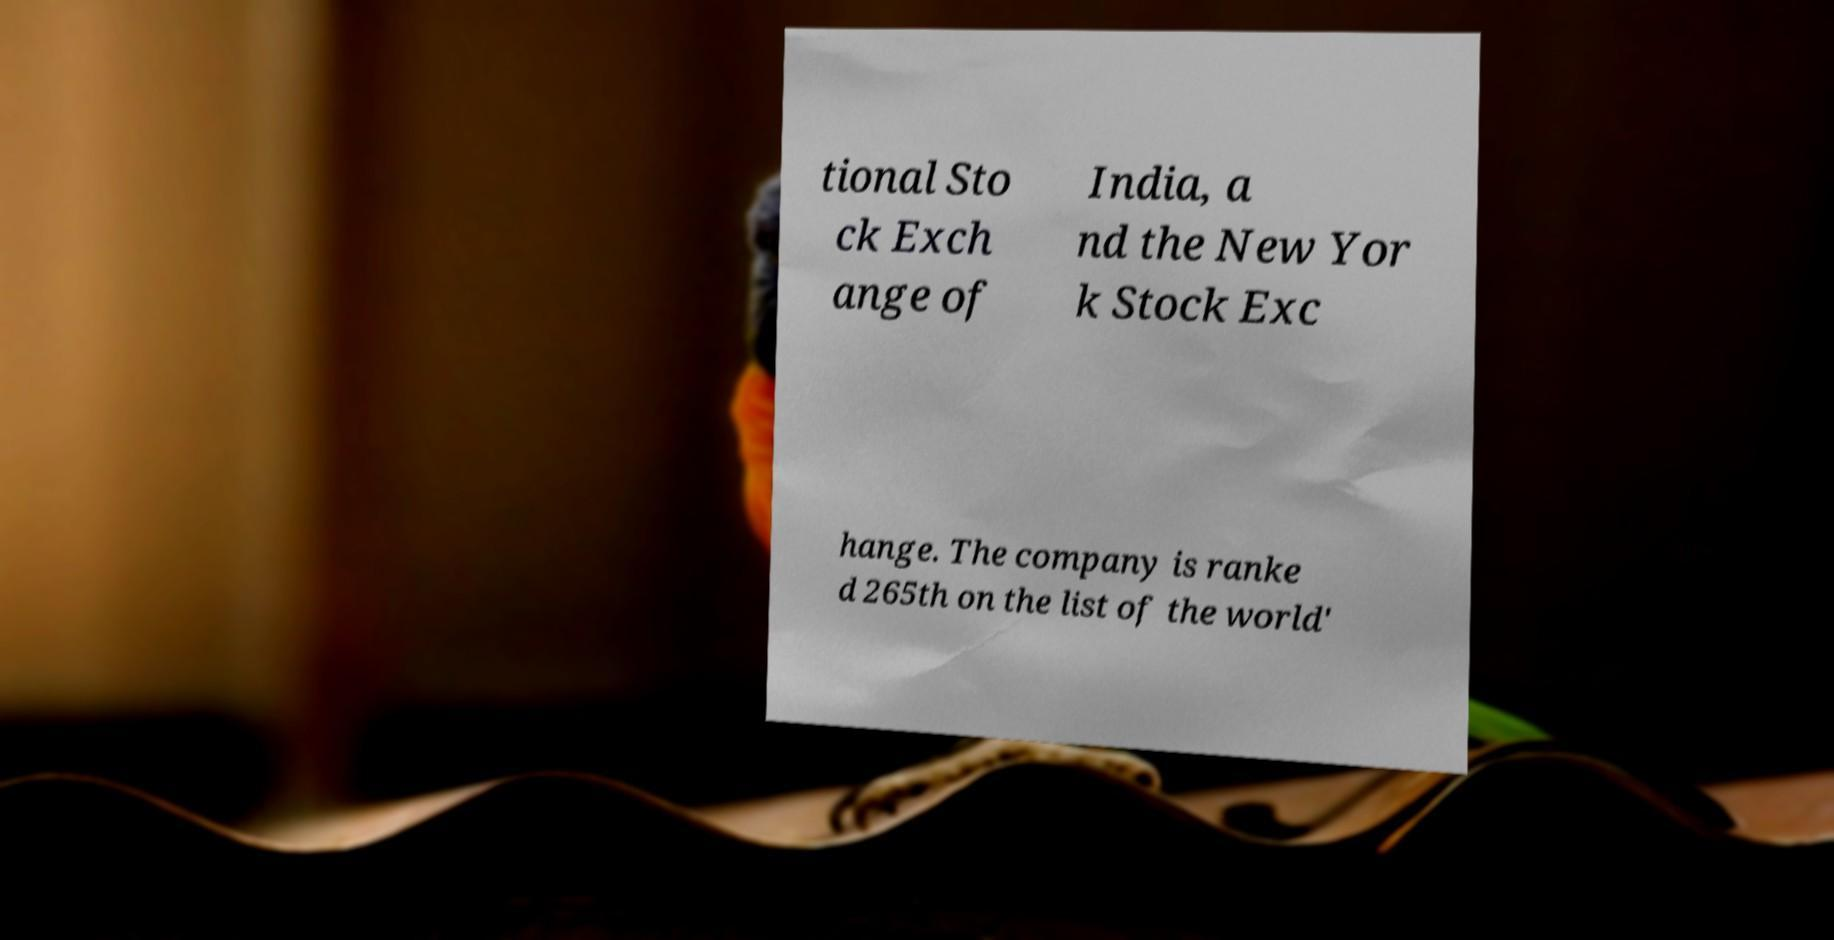Please identify and transcribe the text found in this image. tional Sto ck Exch ange of India, a nd the New Yor k Stock Exc hange. The company is ranke d 265th on the list of the world' 